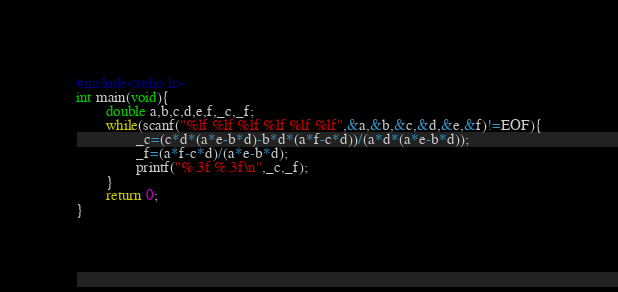Convert code to text. <code><loc_0><loc_0><loc_500><loc_500><_C_>#include<stdio.h>
int main(void){
        double a,b,c,d,e,f,_c,_f;
        while(scanf("%lf %lf %lf %lf %lf %lf",&a,&b,&c,&d,&e,&f)!=EOF){
                _c=(c*d*(a*e-b*d)-b*d*(a*f-c*d))/(a*d*(a*e-b*d));
                _f=(a*f-c*d)/(a*e-b*d);
                printf("%.3f %.3f\n",_c,_f);
        }
        return 0;
}</code> 